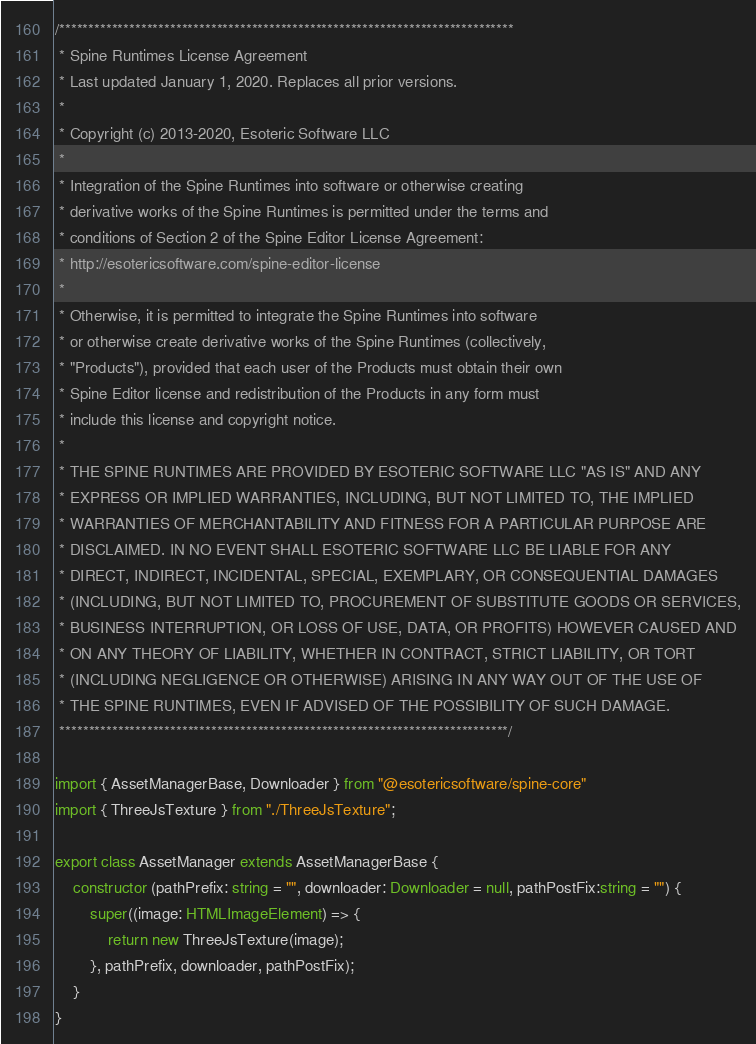<code> <loc_0><loc_0><loc_500><loc_500><_TypeScript_>/******************************************************************************
 * Spine Runtimes License Agreement
 * Last updated January 1, 2020. Replaces all prior versions.
 *
 * Copyright (c) 2013-2020, Esoteric Software LLC
 *
 * Integration of the Spine Runtimes into software or otherwise creating
 * derivative works of the Spine Runtimes is permitted under the terms and
 * conditions of Section 2 of the Spine Editor License Agreement:
 * http://esotericsoftware.com/spine-editor-license
 *
 * Otherwise, it is permitted to integrate the Spine Runtimes into software
 * or otherwise create derivative works of the Spine Runtimes (collectively,
 * "Products"), provided that each user of the Products must obtain their own
 * Spine Editor license and redistribution of the Products in any form must
 * include this license and copyright notice.
 *
 * THE SPINE RUNTIMES ARE PROVIDED BY ESOTERIC SOFTWARE LLC "AS IS" AND ANY
 * EXPRESS OR IMPLIED WARRANTIES, INCLUDING, BUT NOT LIMITED TO, THE IMPLIED
 * WARRANTIES OF MERCHANTABILITY AND FITNESS FOR A PARTICULAR PURPOSE ARE
 * DISCLAIMED. IN NO EVENT SHALL ESOTERIC SOFTWARE LLC BE LIABLE FOR ANY
 * DIRECT, INDIRECT, INCIDENTAL, SPECIAL, EXEMPLARY, OR CONSEQUENTIAL DAMAGES
 * (INCLUDING, BUT NOT LIMITED TO, PROCUREMENT OF SUBSTITUTE GOODS OR SERVICES,
 * BUSINESS INTERRUPTION, OR LOSS OF USE, DATA, OR PROFITS) HOWEVER CAUSED AND
 * ON ANY THEORY OF LIABILITY, WHETHER IN CONTRACT, STRICT LIABILITY, OR TORT
 * (INCLUDING NEGLIGENCE OR OTHERWISE) ARISING IN ANY WAY OUT OF THE USE OF
 * THE SPINE RUNTIMES, EVEN IF ADVISED OF THE POSSIBILITY OF SUCH DAMAGE.
 *****************************************************************************/

import { AssetManagerBase, Downloader } from "@esotericsoftware/spine-core"
import { ThreeJsTexture } from "./ThreeJsTexture";

export class AssetManager extends AssetManagerBase {
	constructor (pathPrefix: string = "", downloader: Downloader = null, pathPostFix:string = "") {
		super((image: HTMLImageElement) => {
			return new ThreeJsTexture(image);
		}, pathPrefix, downloader, pathPostFix);
	}
}
</code> 